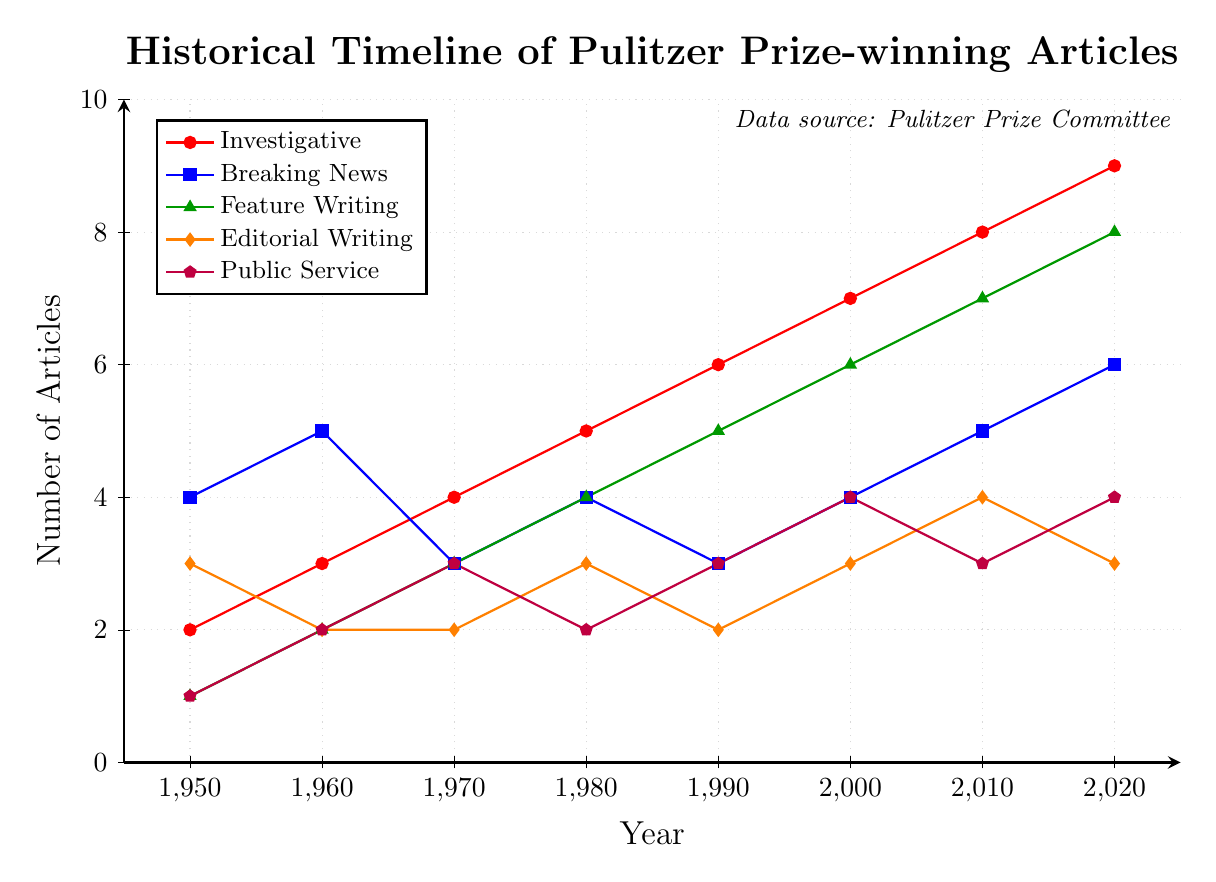Which genre saw the highest increase in the number of Pulitzer Prize-winning articles from 1950 to 2020? Investigative journalism saw the highest increase from 2 articles in 1950 to 9 articles in 2020. The difference is 9 - 2 = 7.
Answer: Investigative From 1980 to 2020, which genre consistently increased in the number of articles? Investigative journalism increased from 5 articles in 1980 to 9 articles in 2020. Feature Writing also showed consistent increase from 4 articles in 1980 to 8 articles in 2020.
Answer: Investigative, Feature Writing What is the total number of Pulitzer Prize-winning articles in the Breaking News genre from 1960 to 2020? The numbers are: 5 (1960), 3 (1970), 4 (1980), 3 (1990), 4 (2000), 5 (2010), 6 (2020). Summing these gives 5 + 3 + 4 + 3 + 4 + 5 + 6 = 30.
Answer: 30 How did the Feature Writing and Public Service articles compare in 1990? In 1990, Feature Writing had 5 articles, while Public Service had 3 articles.
Answer: Feature Writing had more articles Which genre had the least change in the number of articles from 1950 to 2020? Editorial Writing had the least change, going from 3 articles in 1950 to 3 articles in 2020, staying mostly consistent.
Answer: Editorial Writing In which year did Investigative journalism first surpass Breaking News in terms of the number of articles? In 1970, Investigative journalism had 4 articles while Breaking News had 3 articles.
Answer: 1970 What was the combined total of Public Service articles in 1950, 1960, and 1970? The numbers are: 1 (1950), 2 (1960), 3 (1970). Summing these gives: 1 + 2 + 3 = 6.
Answer: 6 What is the average number of Feature Writing articles over the given years? The numbers are: 1 (1950), 2 (1960), 3 (1970), 4 (1980), 5 (1990), 6 (2000), 7 (2010), 8 (2020). Summing these gives: 1 + 2 + 3 + 4 + 5 + 6 + 7 + 8 = 36. The average is 36 / 8 = 4.5.
Answer: 4.5 